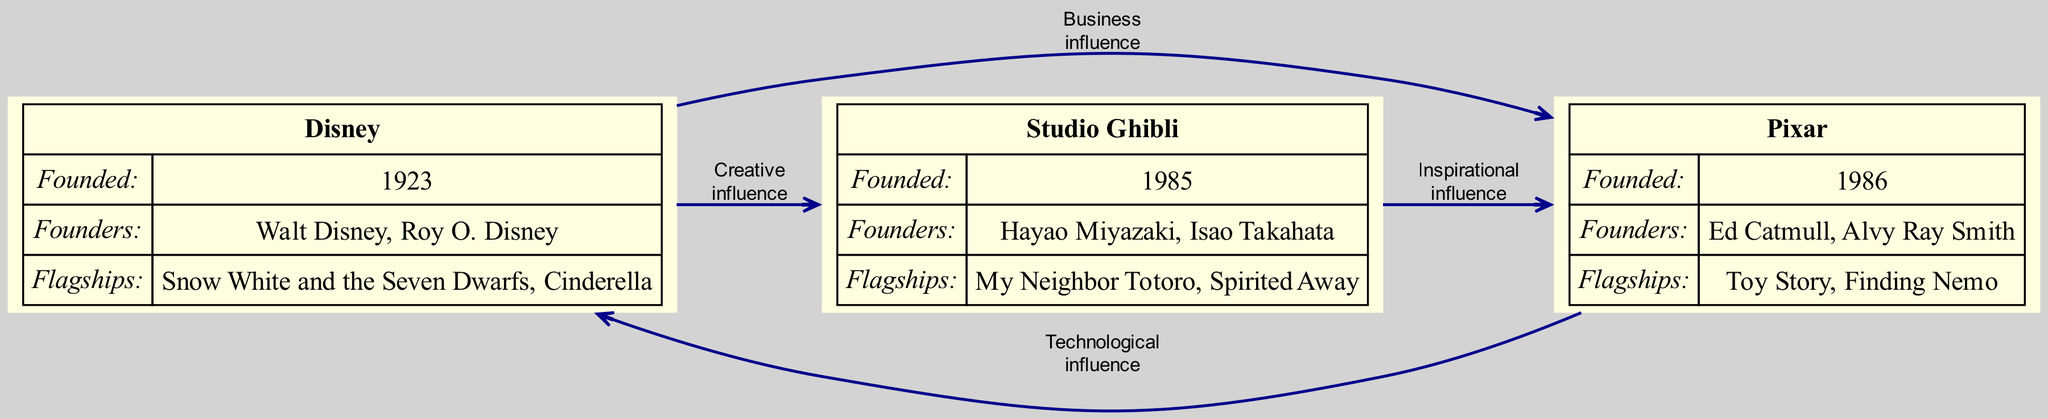What year was Disney founded? The diagram shows the founding year of Disney, which is directly indicated next to the studio's name. It states "Founded: 1923".
Answer: 1923 How many flagship productions does Pixar have listed? The diagram displays a section for flagship productions for each studio. For Pixar, three productions are mentioned: "Toy Story," "Finding Nemo," and "Inside Out." Therefore, the count is three.
Answer: 3 What type of influence did Disney have on Studio Ghibli? The diagram indicates that the influence from Disney to Studio Ghibli is categorized as "creative." This is shown alongside the influence details listed in the diagram.
Answer: Creative Who are the founders of Studio Ghibli? The diagram includes a section detailing the founders of each studio. For Studio Ghibli, it lists "Hayao Miyazaki" and "Isao Takahata" as the founders.
Answer: Hayao Miyazaki, Isao Takahata What was Pixar's flagship production that was released first? The diagram lists Pixar’s flagship productions in the order they were provided. The first production mentioned is "Toy Story."
Answer: Toy Story How are Pixar and Disney related in terms of ownership? According to the diagram, there is an edge labeled as “business influence” originating from Disney to Pixar, indicating that Disney acquired Pixar in 2006, highlighting the ownership relationship.
Answer: Acquired Which studio is influenced by Japanese folklore? The influences for each studio mentioned in the diagram indicate that Studio Ghibli is influenced by "Japanese folklore." This information is specifically stated in the influences section.
Answer: Studio Ghibli What type of innovation did Pixar contribute to Disney? From the diagram, the influence from Pixar to Disney is labeled as "technological," showing that Pixar's contributions in computer-generated imagery were adopted by Disney.
Answer: Technological What influence did Studio Ghibli have on Pixar? The diagram indicates that the influence from Studio Ghibli to Pixar is "inspirational." This influence is noted alongside the relevant information connecting the two studios.
Answer: Inspirational How many animation studios are present in the diagram? The diagram includes three animation studios: Disney, Pixar, and Studio Ghibli. By counting these studios listed, we find there are three in total.
Answer: 3 